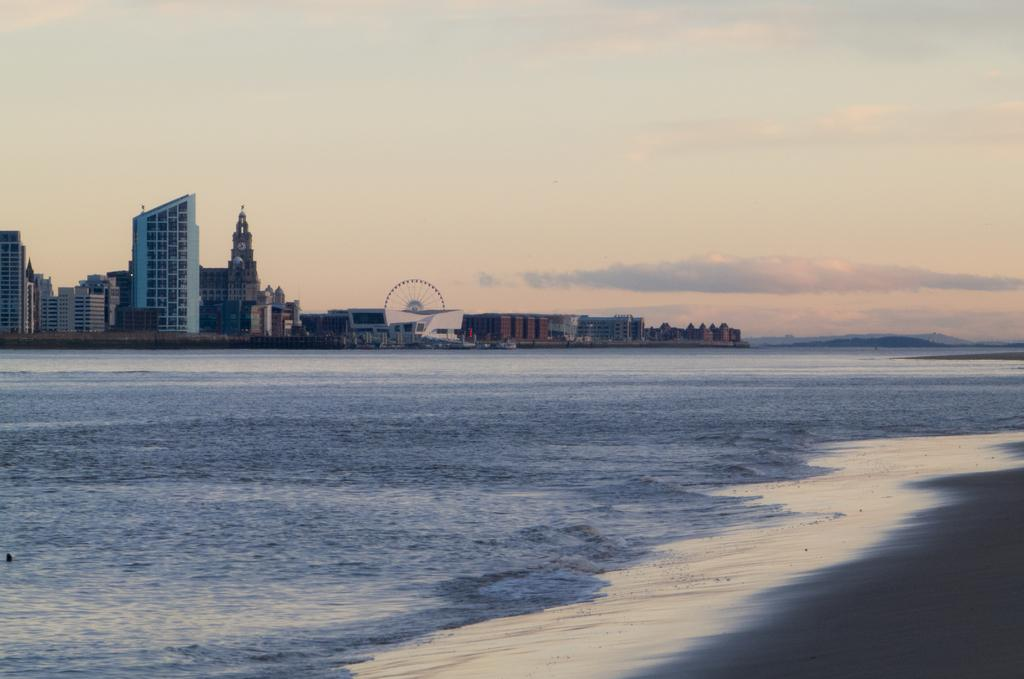What is the main feature of the image? The main feature of the image is an ocean. What can be seen in the background of the image? There are buildings in the background of the image. What is visible in the sky in the image? Clouds are visible in the sky in the image. What type of earth can be seen in the image? There is no specific type of earth mentioned or visible in the image; it simply features an ocean, buildings, and clouds. 